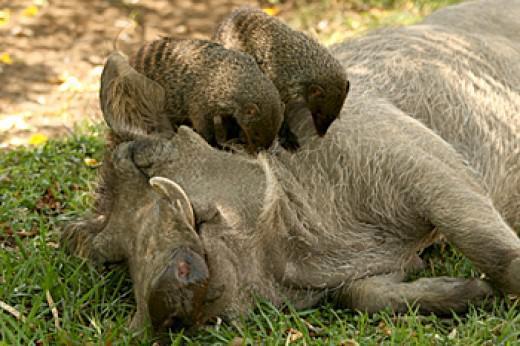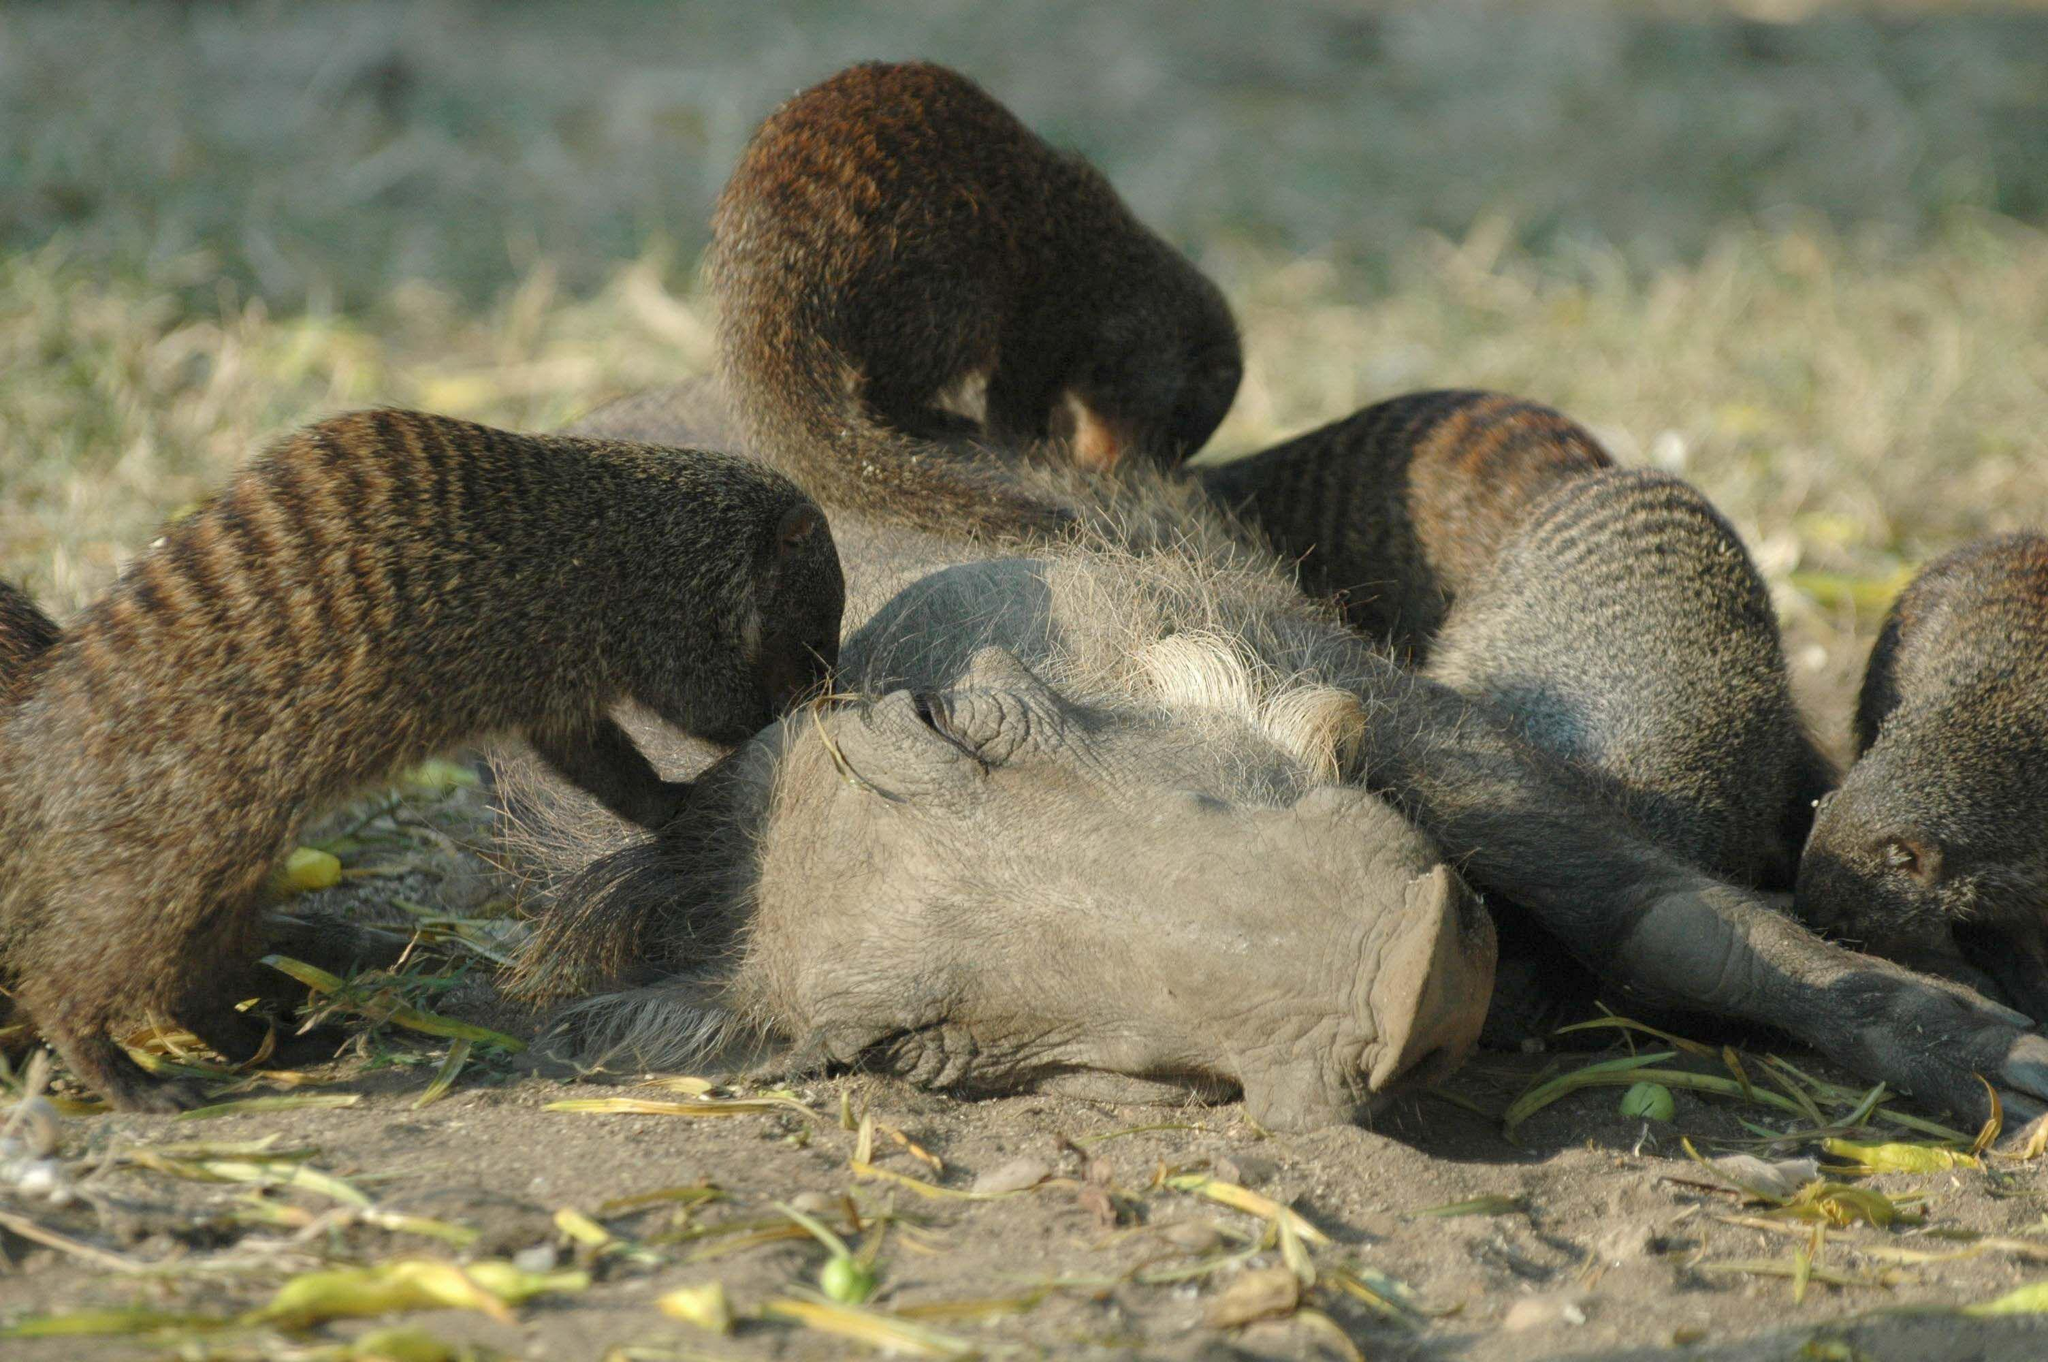The first image is the image on the left, the second image is the image on the right. Considering the images on both sides, is "Each image shows multiple small striped mammals crawling on and around one warthog, and the warthogs in the two images are in the same type of pose." valid? Answer yes or no. Yes. 